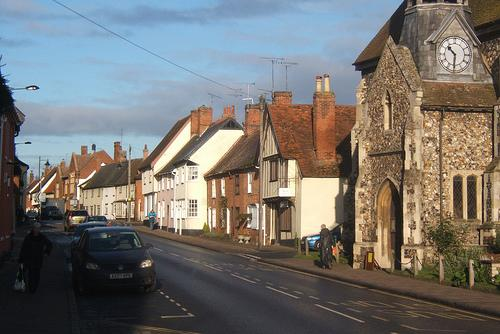What is the person on the left standing next to? car 